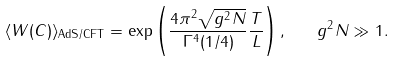<formula> <loc_0><loc_0><loc_500><loc_500>\langle W ( C ) \rangle _ { \text {AdS/CFT} } = \exp \left ( \frac { 4 \pi ^ { 2 } \sqrt { g ^ { 2 } N } } { \Gamma ^ { 4 } ( 1 / 4 ) } \frac { T } { L } \right ) , \quad g ^ { 2 } N \gg 1 .</formula> 